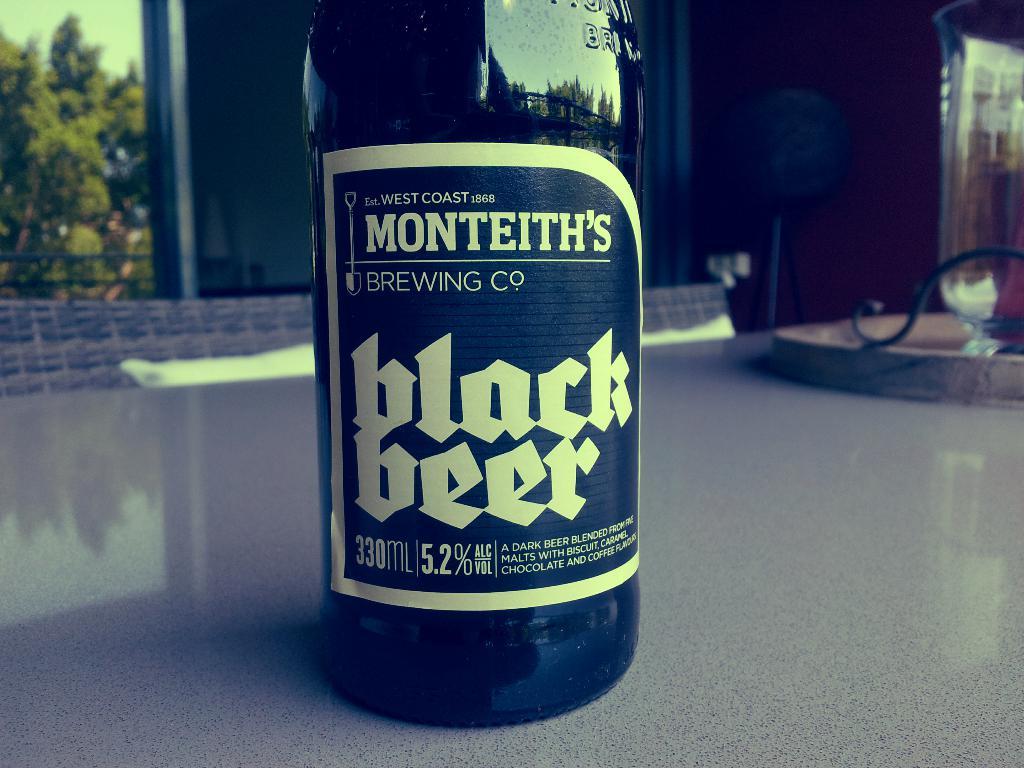What is the name of the brewing company?
Offer a terse response. Monteith's. 